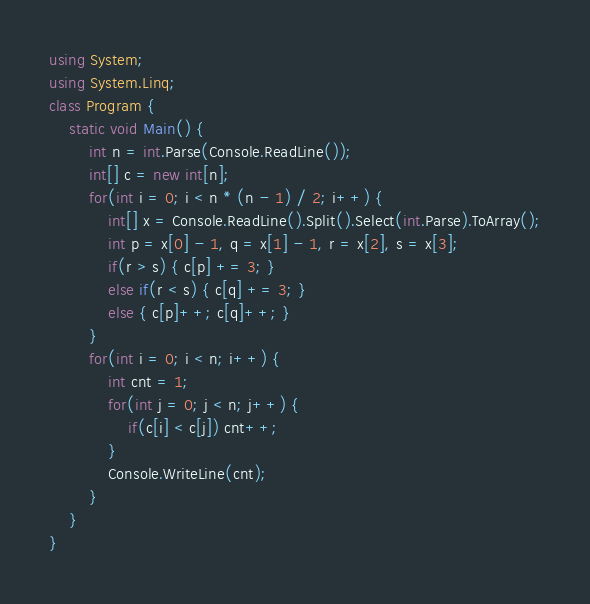<code> <loc_0><loc_0><loc_500><loc_500><_C#_>using System;
using System.Linq;
class Program {
	static void Main() {
		int n = int.Parse(Console.ReadLine());
		int[] c = new int[n];
		for(int i = 0; i < n * (n - 1) / 2; i++) {
			int[] x = Console.ReadLine().Split().Select(int.Parse).ToArray();
			int p = x[0] - 1, q = x[1] - 1, r = x[2], s = x[3];
			if(r > s) { c[p] += 3; }
			else if(r < s) { c[q] += 3; }
			else { c[p]++; c[q]++; }
		}
		for(int i = 0; i < n; i++) {
			int cnt = 1;
			for(int j = 0; j < n; j++) {
				if(c[i] < c[j]) cnt++;
			}
			Console.WriteLine(cnt);
		}
	}
}</code> 